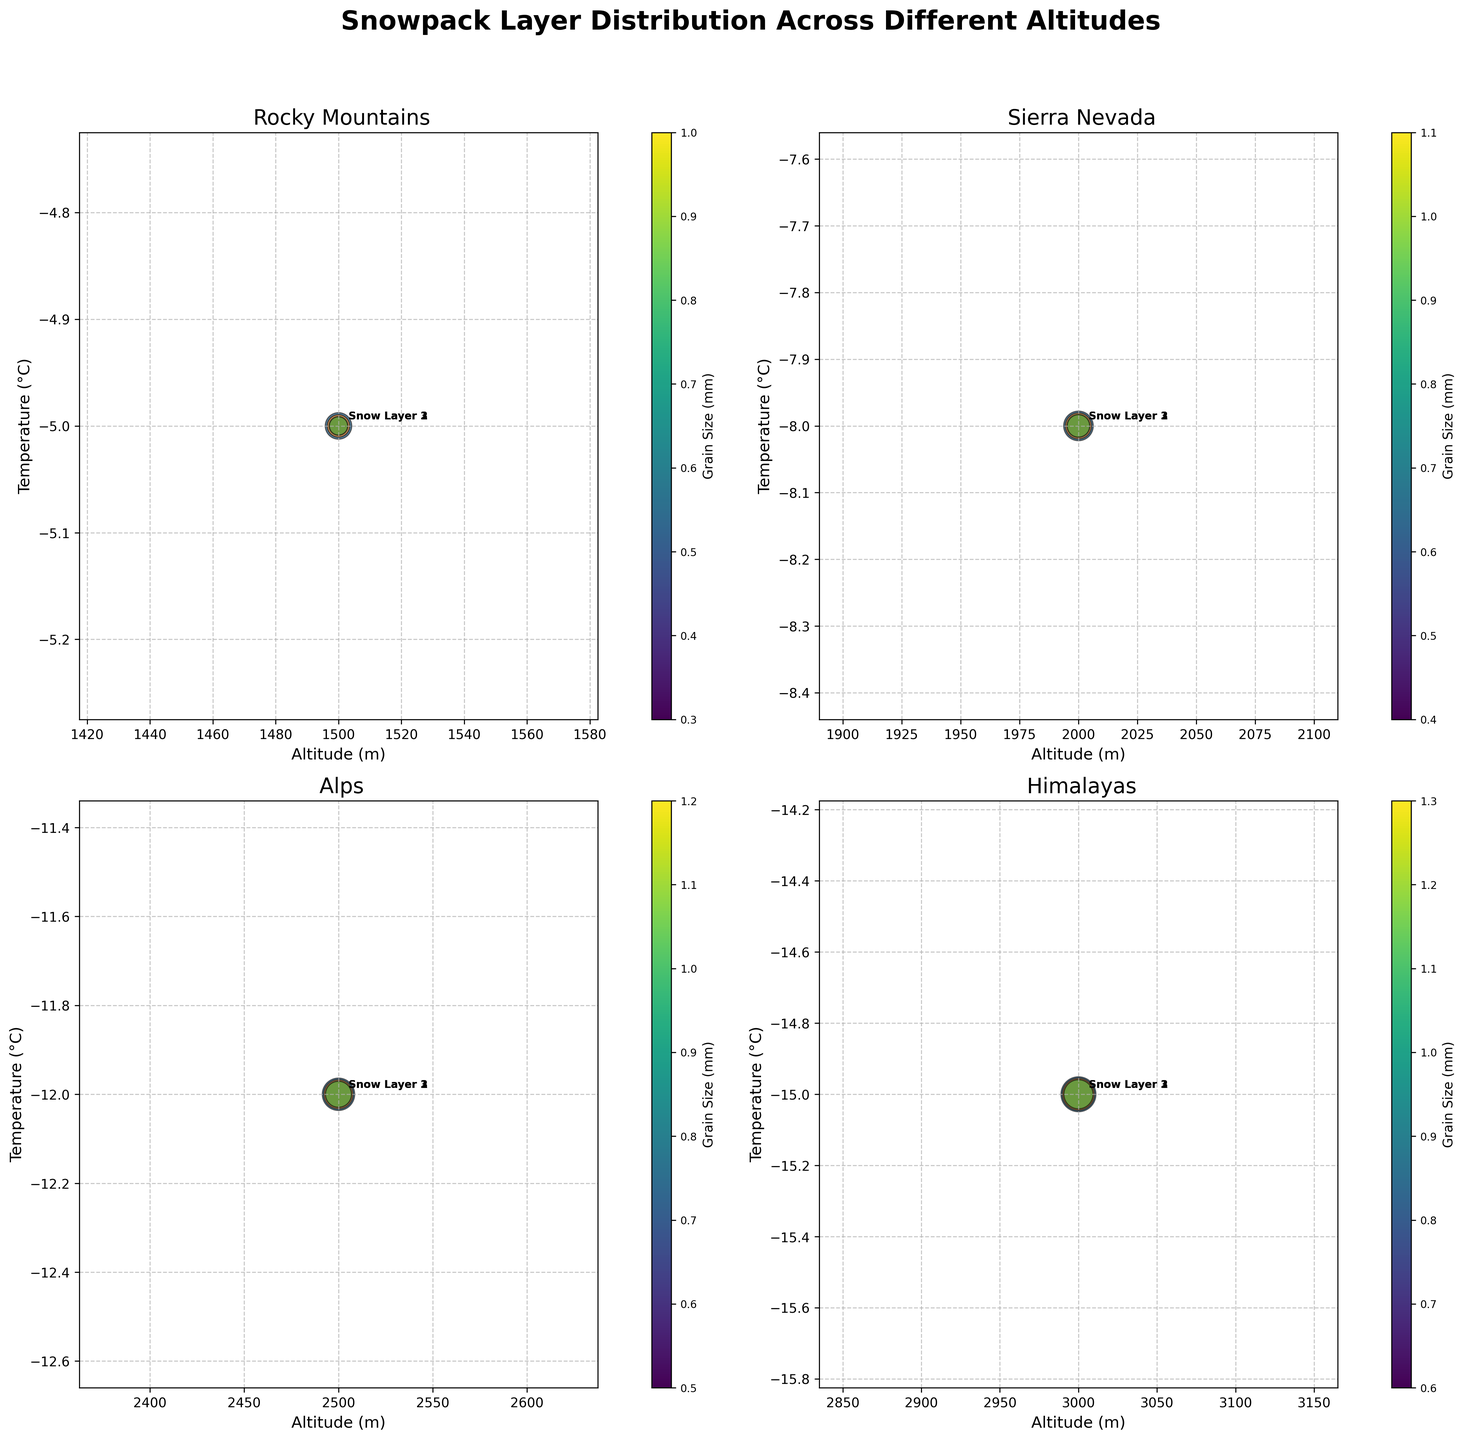What is the title of the figure? The title is usually located at the top of the figure, in this case, it reads "Snowpack Layer Distribution Across Different Altitudes".
Answer: Snowpack Layer Distribution Across Different Altitudes What are the x and y-axis labels? The x and y-axis labels provide context for the data. Here, the x-axis is labeled 'Altitude (m)' and the y-axis is labeled 'Temperature (°C)'.
Answer: Altitude (m), Temperature (°C) Which location shows data at the highest altitude? By observing the x-axis values across subplots, the highest altitude data point appears in the subplot labeled "Himalayas".
Answer: Himalayas In the Sierra Nevada subplot, which snow layer appears at an altitude of 2000 meters? Look at the Sierra Nevada subplot and identify the label closest to the 2000-meter mark on the x-axis. The snow layers are explicitly annotated, and "Snow Layer 1" appears at that altitude.
Answer: Snow Layer 1 What is the grain size range in the Rocky Mountains subplot? Check the colorbar legend and note the range values that correspond to grain sizes in the Rocky Mountains subplot. The minimum grain size for this subplot starts at 0.3 mm and goes up to 1.0 mm.
Answer: 0.3 mm - 1.0 mm Which location has the coldest temperature data points? Compare the y-axis values across subplots to determine the lowest temperature. The Himalayas subplot shows the coldest temperature at -15°C.
Answer: Himalayas Which snow layer in the Alps has the smallest grain size? Refer to the Alps subplot, identify the data points and their annotations, and check the color gradient of the bubbles. "Snow Layer 1" in the Alps has the smallest grain size of 0.5 mm.
Answer: Snow Layer 1 How many snow layers are depicted in each subplot? Observe each subplot and count the number of annotated snow layers. Each subplot consistently shows three snow layers.
Answer: 3 Which snow layer at 2500 meters in the Alps has the greatest depth? Look at the annotated labels for the 2500 meters altitude in the Alps subplot, and compare the size of bubbles indicating depth. "Snow Layer 1" has the greatest depth of 30 mm.
Answer: Snow Layer 1 What color represents the snow layers in the Himalayas subplot? Examine the colors used in the Himalayas subplot. They are typically unique to this subplot for differentiation and here are shades of blue, green, and yellow (assuming usage of `viridis` colormap).
Answer: shades of blue, green, and yellow 